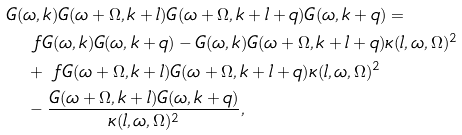Convert formula to latex. <formula><loc_0><loc_0><loc_500><loc_500>& G ( \omega , k ) G ( \omega + \Omega , k + l ) G ( \omega + \Omega , k + l + q ) G ( \omega , k + q ) = \\ & \quad \ f { G ( \omega , k ) G ( \omega , k + q ) - G ( \omega , k ) G ( \omega + \Omega , k + l + q ) } { \kappa ( l , \omega , \Omega ) ^ { 2 } } \\ & \quad + \ f { G ( \omega + \Omega , k + l ) G ( \omega + \Omega , k + l + q ) } { \kappa ( l , \omega , \Omega ) ^ { 2 } } \\ & \quad - \frac { G ( \omega + \Omega , k + l ) G ( \omega , k + q ) } { \kappa ( l , \omega , \Omega ) ^ { 2 } } ,</formula> 